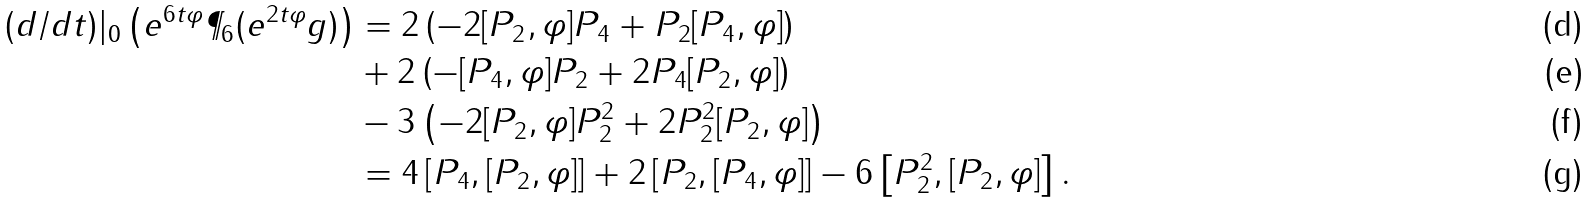<formula> <loc_0><loc_0><loc_500><loc_500>( d / d t ) | _ { 0 } \left ( e ^ { 6 t \varphi } \P _ { 6 } ( e ^ { 2 t \varphi } g ) \right ) & = 2 \left ( - 2 [ P _ { 2 } , \varphi ] P _ { 4 } + P _ { 2 } [ P _ { 4 } , \varphi ] \right ) \\ & + 2 \left ( - [ P _ { 4 } , \varphi ] P _ { 2 } + 2 P _ { 4 } [ P _ { 2 } , \varphi ] \right ) \\ & - 3 \left ( - 2 [ P _ { 2 } , \varphi ] P _ { 2 } ^ { 2 } + 2 P _ { 2 } ^ { 2 } [ P _ { 2 } , \varphi ] \right ) \\ & = 4 \left [ P _ { 4 } , [ P _ { 2 } , \varphi ] \right ] + 2 \left [ P _ { 2 } , [ P _ { 4 } , \varphi ] \right ] - 6 \left [ P _ { 2 } ^ { 2 } , [ P _ { 2 } , \varphi ] \right ] .</formula> 